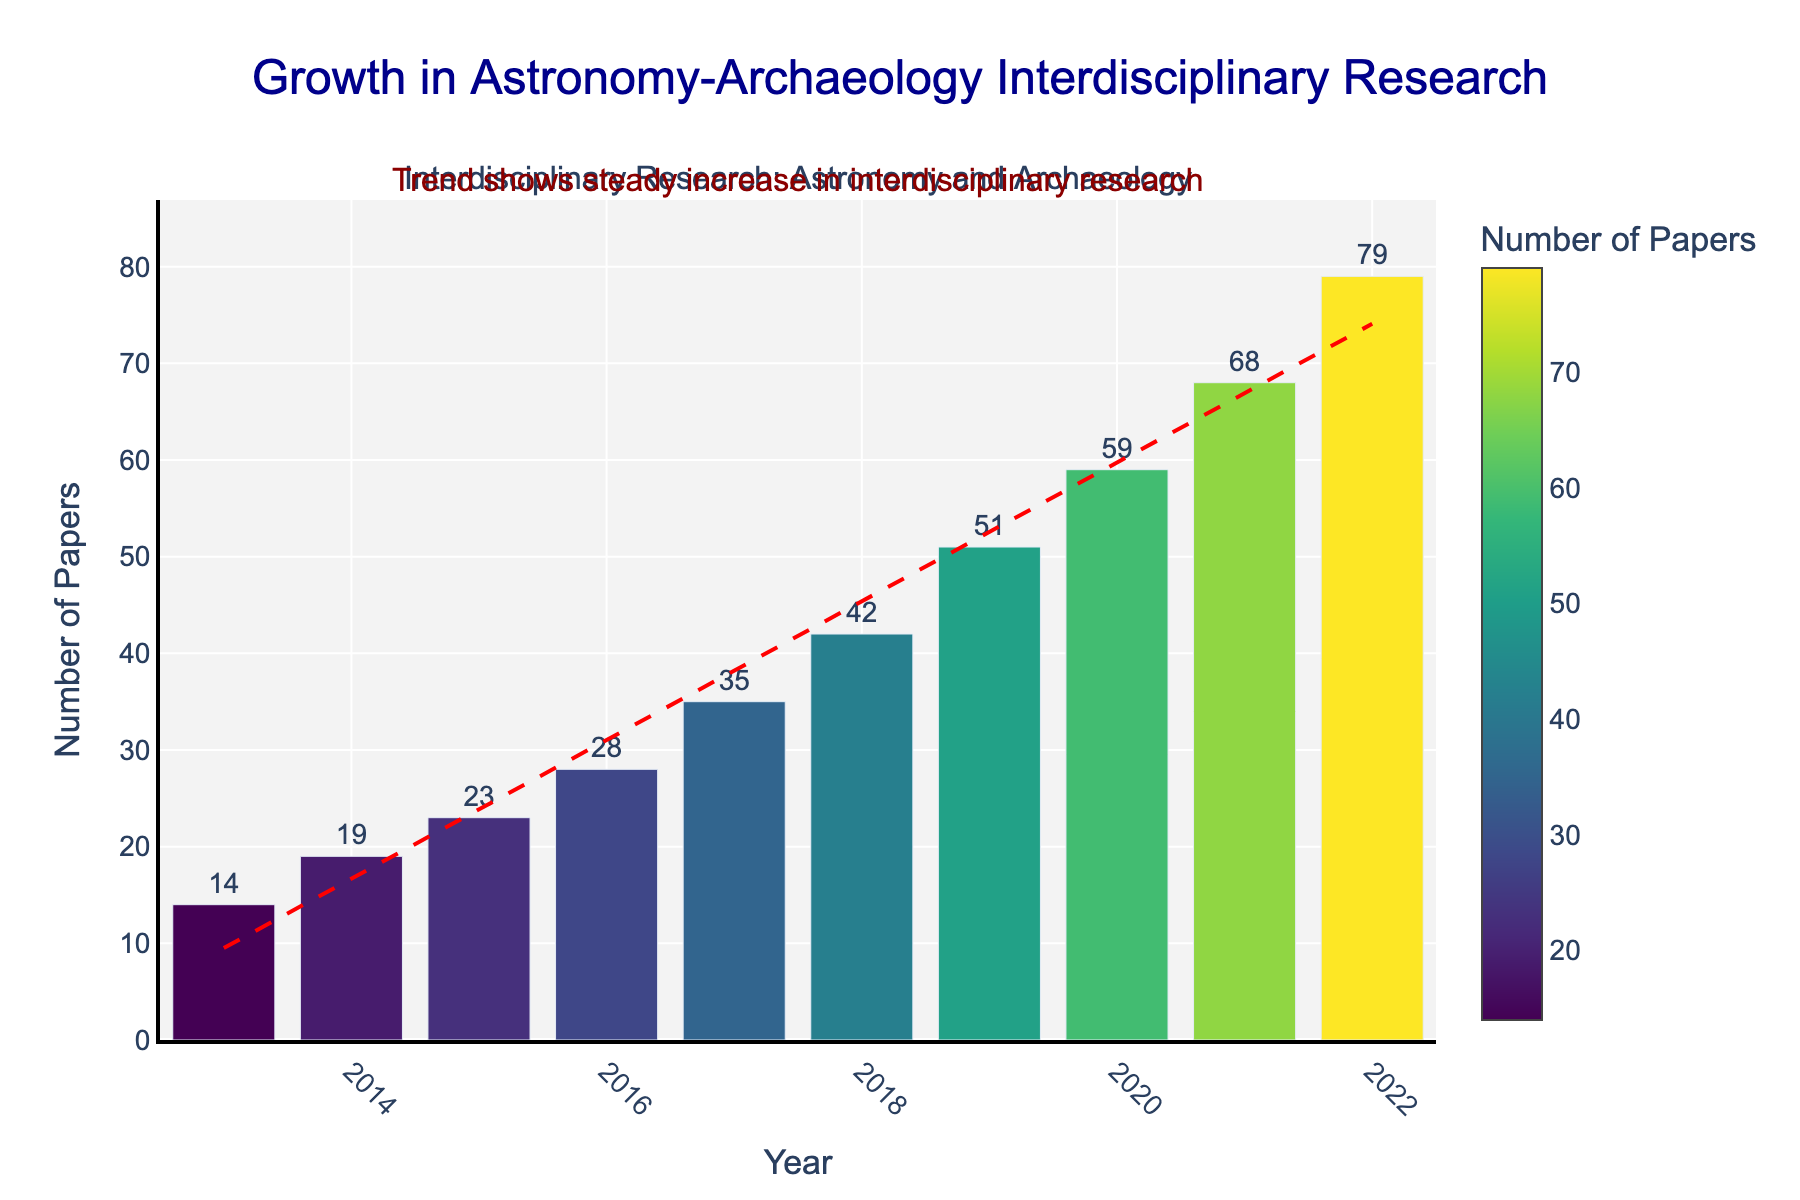Which year saw the highest number of interdisciplinary research papers published? The year 2022 has the highest bar in the chart, reaching 79 papers, indicating it saw the highest number of publications.
Answer: 2022 How many more papers were published in 2022 compared to 2013? The figure shows that 79 papers were published in 2022 and 14 in 2013. The difference is calculated as 79 - 14 = 65.
Answer: 65 By how much did the number of papers increase from 2015 to 2016? The figure indicates that 23 papers were published in 2015 and 28 in 2016. The increase is 28 - 23 = 5.
Answer: 5 Which year had the sharpest increase in the number of papers published compared to the previous year? By observing the heights of the bars, the largest jump occurs between 2021 and 2022, increasing from 68 to 79 papers.
Answer: 2021 to 2022 What is the average number of papers published per year over the past decade? Sum of papers over each year: 14 + 19 + 23 + 28 + 35 + 42 + 51 + 59 + 68 + 79 = 418. Dividing by 10 years, the average is 418/10 = 41.8.
Answer: 41.8 Which year marks the beginning of a noticeable trend in the increase in publications? Visually, from 2017 to 2018, there's a distinct steep increase in the slope of the trendline, making 2017 the starting point of significant growth.
Answer: 2017 How many years saw an increase of more than 10 papers compared to the previous year? Observing the bars: from 2017 to 2018 (35 to 42, +7), 2018 to 2019 (42 to 51, +9), 2019 to 2020 (51 to 59, +8), 2020 to 2021 (59 to 68, +9), 2021 to 2022 (68 to 79, +11). Only 1 year (2021 to 2022) saw an increase of more than 10 papers.
Answer: 1 Which years had less than 30 papers published? From the chart, the years 2013 to 2016 had less than 30 papers published: specifically, 14, 19, 23, and 28 papers respectively.
Answer: 2013 to 2016 What is the overall trend shown by the red dashed line in the plot? The trend line consistently slopes upward, indicating a steady increase in the number of interdisciplinary research papers over the decade.
Answer: Steady increase 